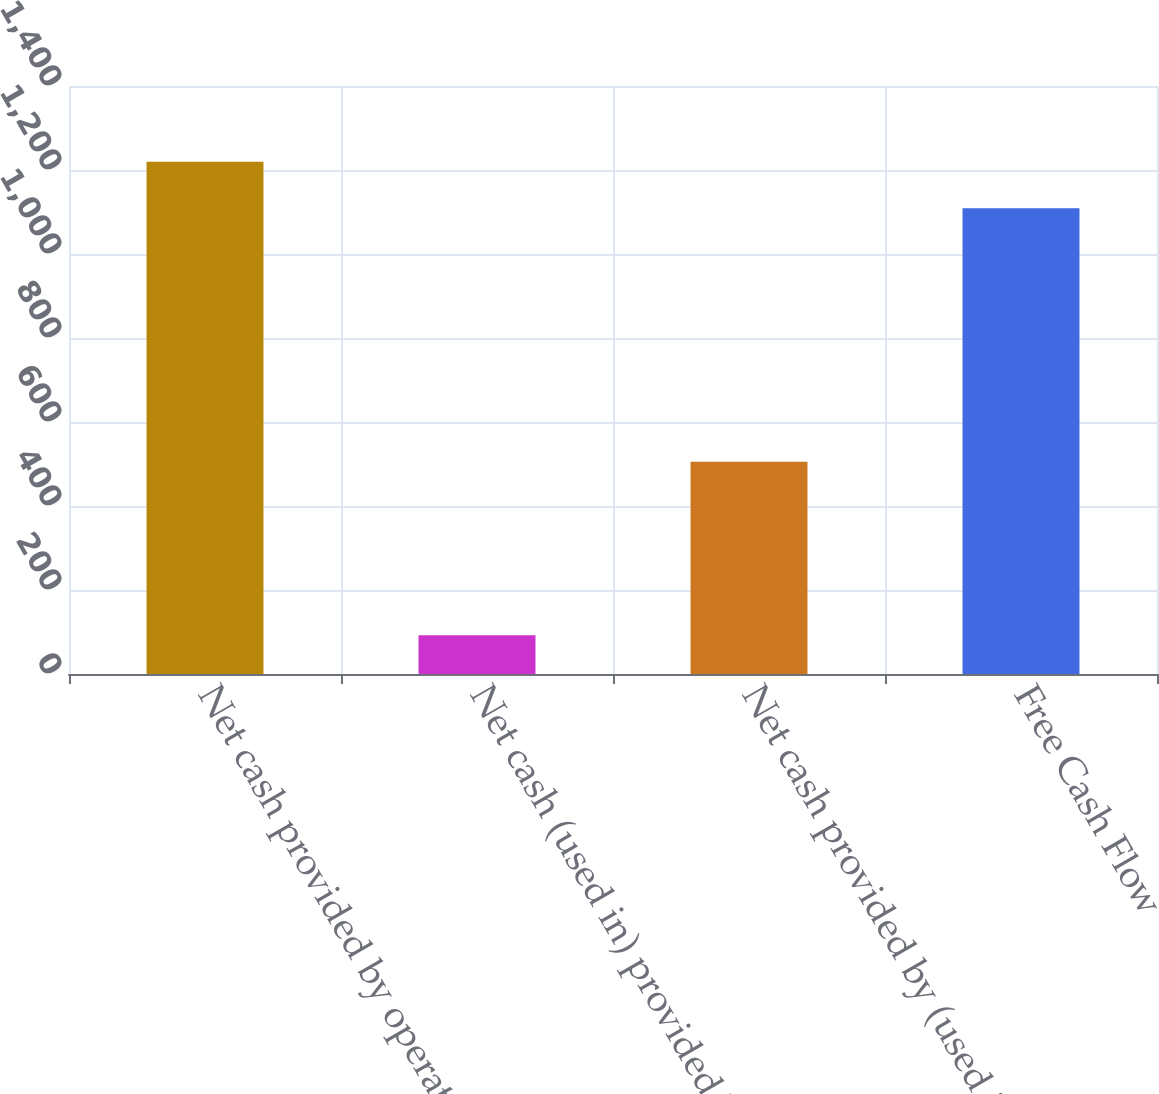<chart> <loc_0><loc_0><loc_500><loc_500><bar_chart><fcel>Net cash provided by operating<fcel>Net cash (used in) provided by<fcel>Net cash provided by (used in)<fcel>Free Cash Flow<nl><fcel>1219.71<fcel>92<fcel>505.5<fcel>1109.1<nl></chart> 